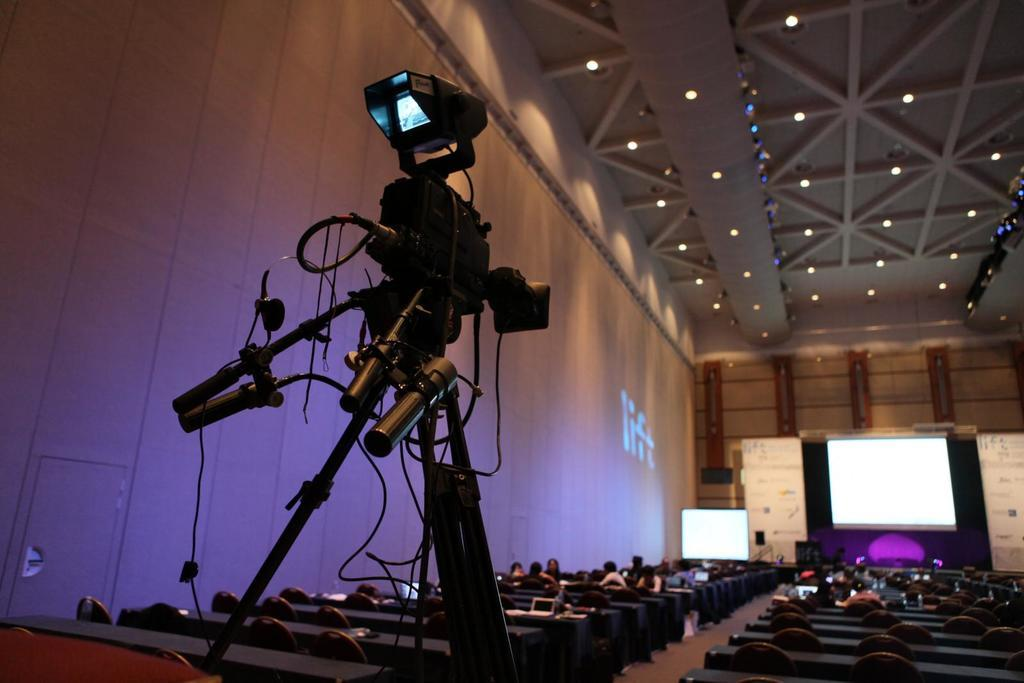What are the people in the image doing? The people in the image are sitting on chairs. What can be seen on the walls in the image? There are white color boards on the walls in the image. What type of display devices are present in the image? There are screens in the image. What is the background of the image made of? There is a wall in the image. What type of lighting is present in the image? There are lights in the image. What equipment is used for recording in the image? There is a camera on a stand in the image. What type of ticket is required to enter the room in the image? There is no mention of a ticket or any requirement for entry in the image. 